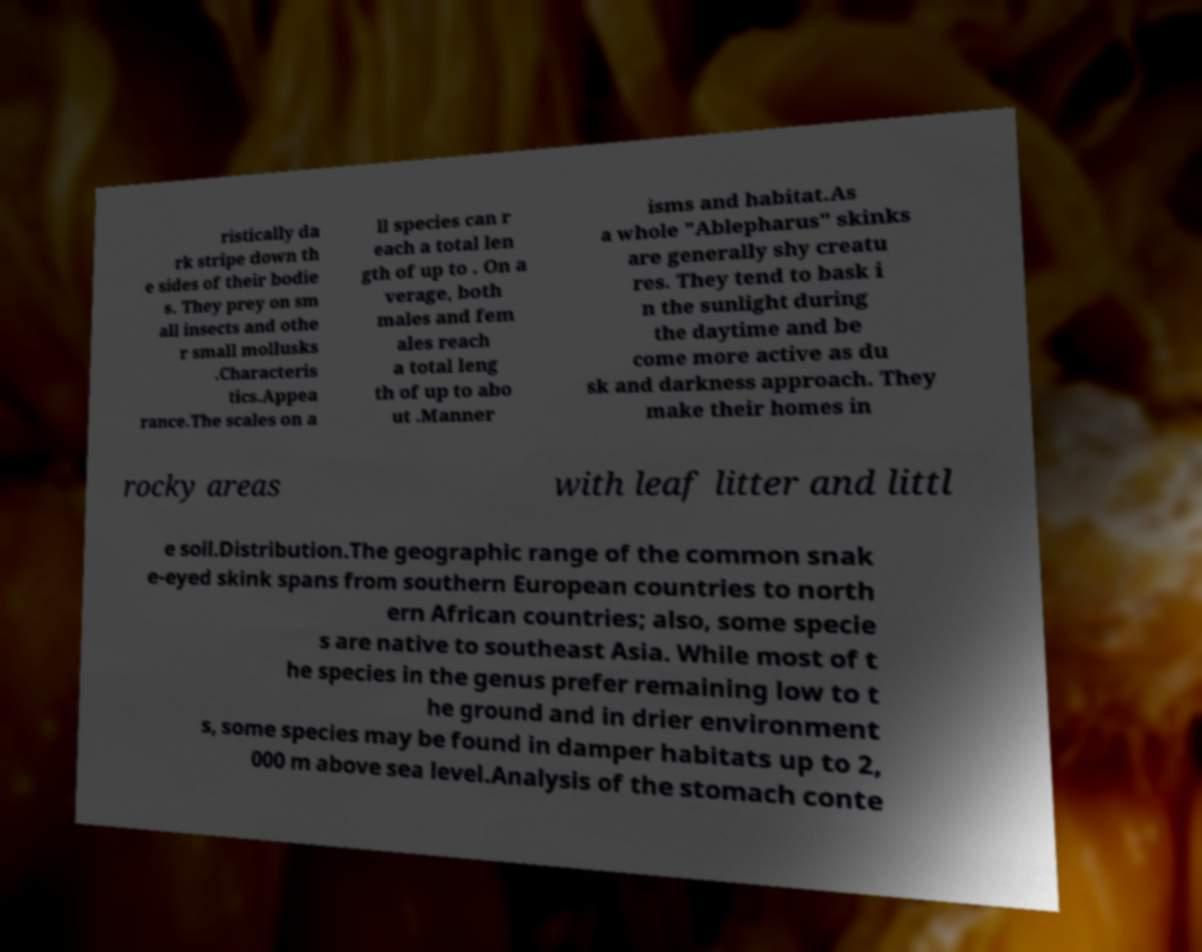Could you extract and type out the text from this image? ristically da rk stripe down th e sides of their bodie s. They prey on sm all insects and othe r small mollusks .Characteris tics.Appea rance.The scales on a ll species can r each a total len gth of up to . On a verage, both males and fem ales reach a total leng th of up to abo ut .Manner isms and habitat.As a whole "Ablepharus" skinks are generally shy creatu res. They tend to bask i n the sunlight during the daytime and be come more active as du sk and darkness approach. They make their homes in rocky areas with leaf litter and littl e soil.Distribution.The geographic range of the common snak e-eyed skink spans from southern European countries to north ern African countries; also, some specie s are native to southeast Asia. While most of t he species in the genus prefer remaining low to t he ground and in drier environment s, some species may be found in damper habitats up to 2, 000 m above sea level.Analysis of the stomach conte 